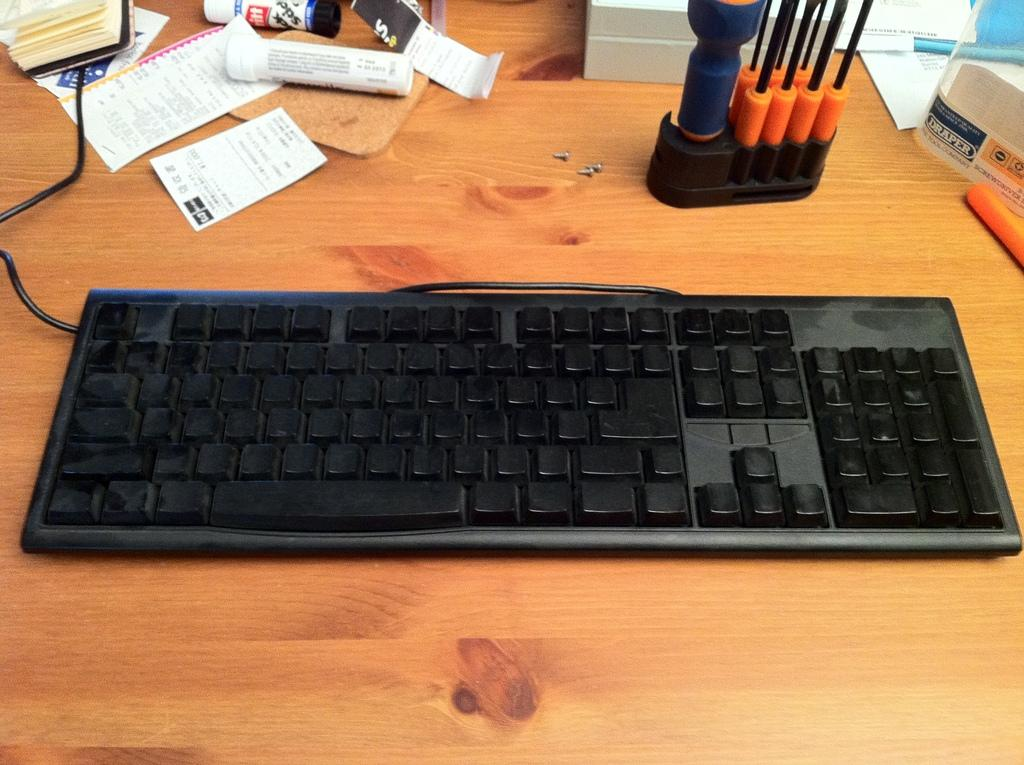<image>
Summarize the visual content of the image. A container that says "DRAPER" sits off to the right of a keyboard. 